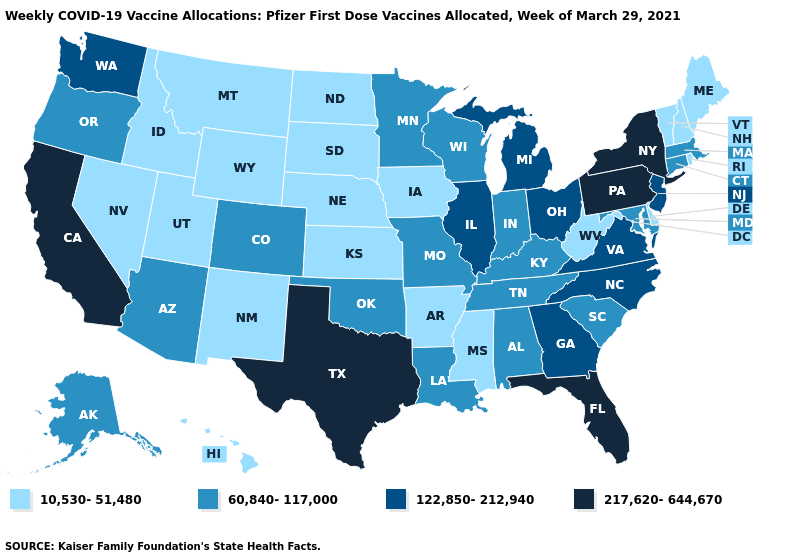What is the value of Alabama?
Answer briefly. 60,840-117,000. What is the highest value in the USA?
Short answer required. 217,620-644,670. What is the value of Oregon?
Keep it brief. 60,840-117,000. Does Connecticut have the lowest value in the Northeast?
Be succinct. No. What is the value of Michigan?
Short answer required. 122,850-212,940. What is the value of New Jersey?
Answer briefly. 122,850-212,940. What is the value of Arkansas?
Be succinct. 10,530-51,480. What is the lowest value in the USA?
Short answer required. 10,530-51,480. What is the value of Minnesota?
Give a very brief answer. 60,840-117,000. Does North Carolina have a lower value than Georgia?
Answer briefly. No. Does the first symbol in the legend represent the smallest category?
Write a very short answer. Yes. Which states hav the highest value in the West?
Keep it brief. California. 